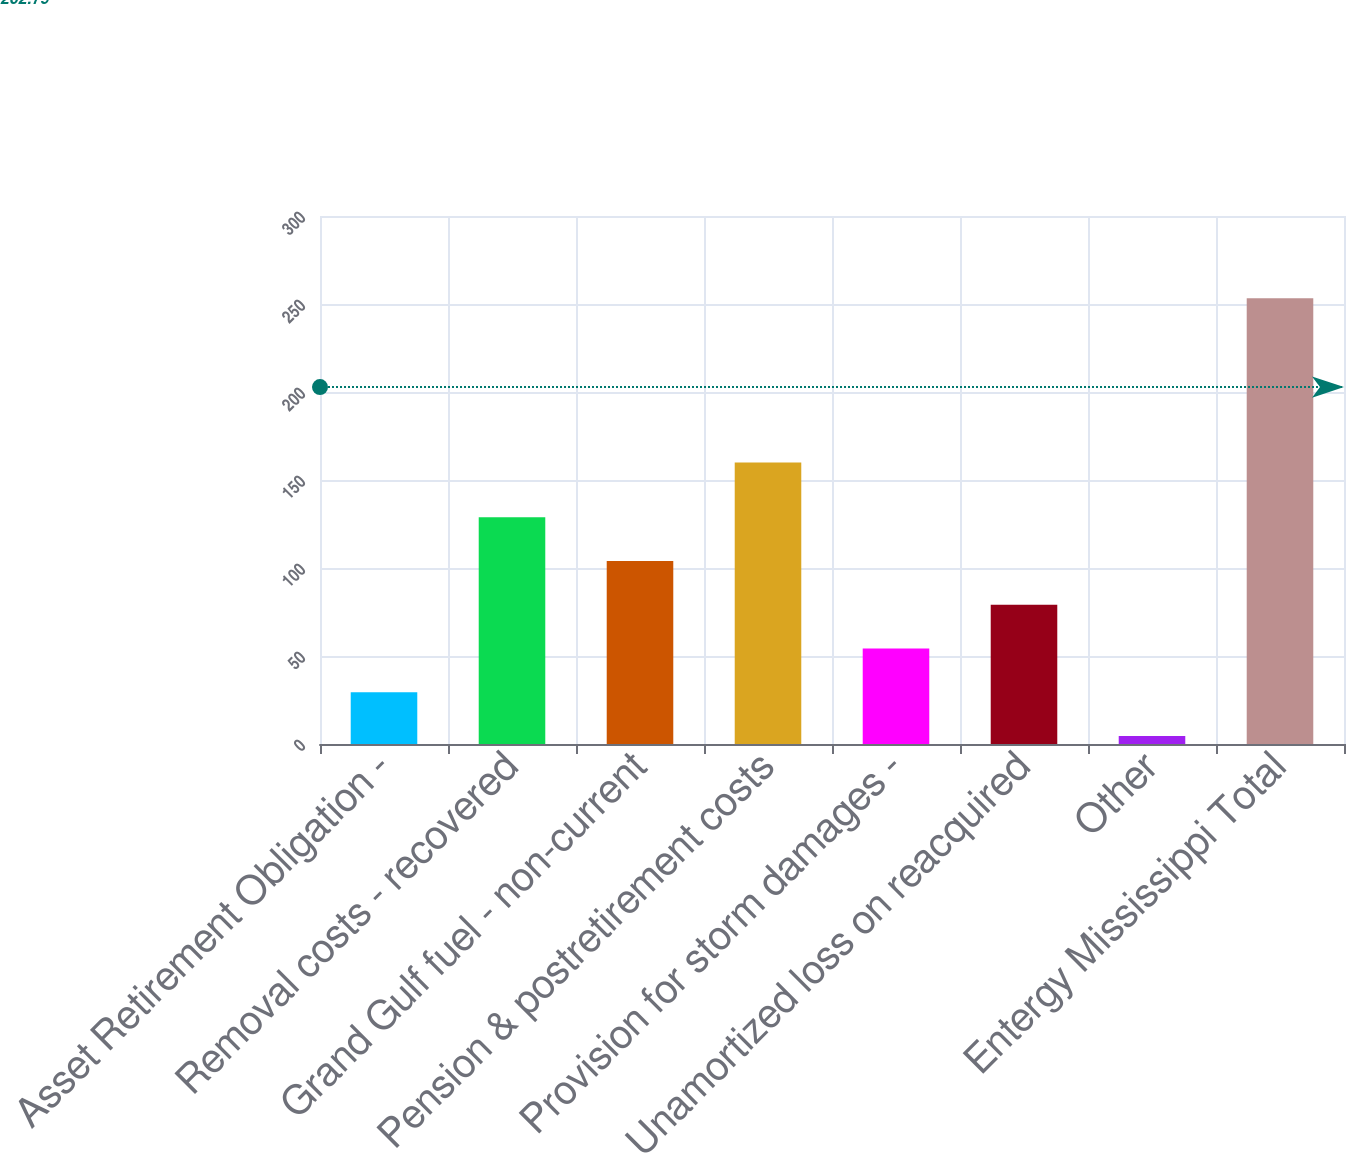Convert chart. <chart><loc_0><loc_0><loc_500><loc_500><bar_chart><fcel>Asset Retirement Obligation -<fcel>Removal costs - recovered<fcel>Grand Gulf fuel - non-current<fcel>Pension & postretirement costs<fcel>Provision for storm damages -<fcel>Unamortized loss on reacquired<fcel>Other<fcel>Entergy Mississippi Total<nl><fcel>29.37<fcel>128.85<fcel>103.98<fcel>160<fcel>54.24<fcel>79.11<fcel>4.5<fcel>253.2<nl></chart> 